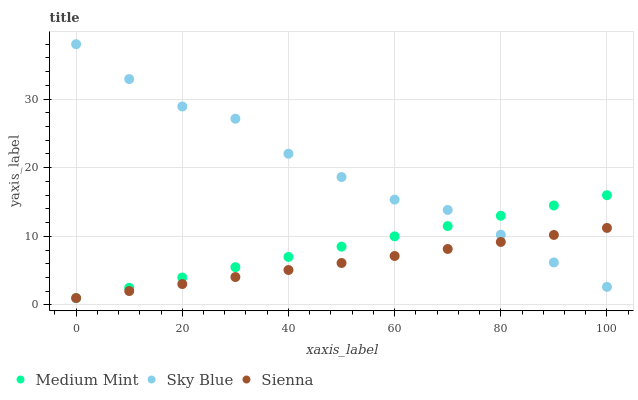Does Sienna have the minimum area under the curve?
Answer yes or no. Yes. Does Sky Blue have the maximum area under the curve?
Answer yes or no. Yes. Does Sky Blue have the minimum area under the curve?
Answer yes or no. No. Does Sienna have the maximum area under the curve?
Answer yes or no. No. Is Sienna the smoothest?
Answer yes or no. Yes. Is Sky Blue the roughest?
Answer yes or no. Yes. Is Sky Blue the smoothest?
Answer yes or no. No. Is Sienna the roughest?
Answer yes or no. No. Does Medium Mint have the lowest value?
Answer yes or no. Yes. Does Sky Blue have the lowest value?
Answer yes or no. No. Does Sky Blue have the highest value?
Answer yes or no. Yes. Does Sienna have the highest value?
Answer yes or no. No. Does Sky Blue intersect Medium Mint?
Answer yes or no. Yes. Is Sky Blue less than Medium Mint?
Answer yes or no. No. Is Sky Blue greater than Medium Mint?
Answer yes or no. No. 